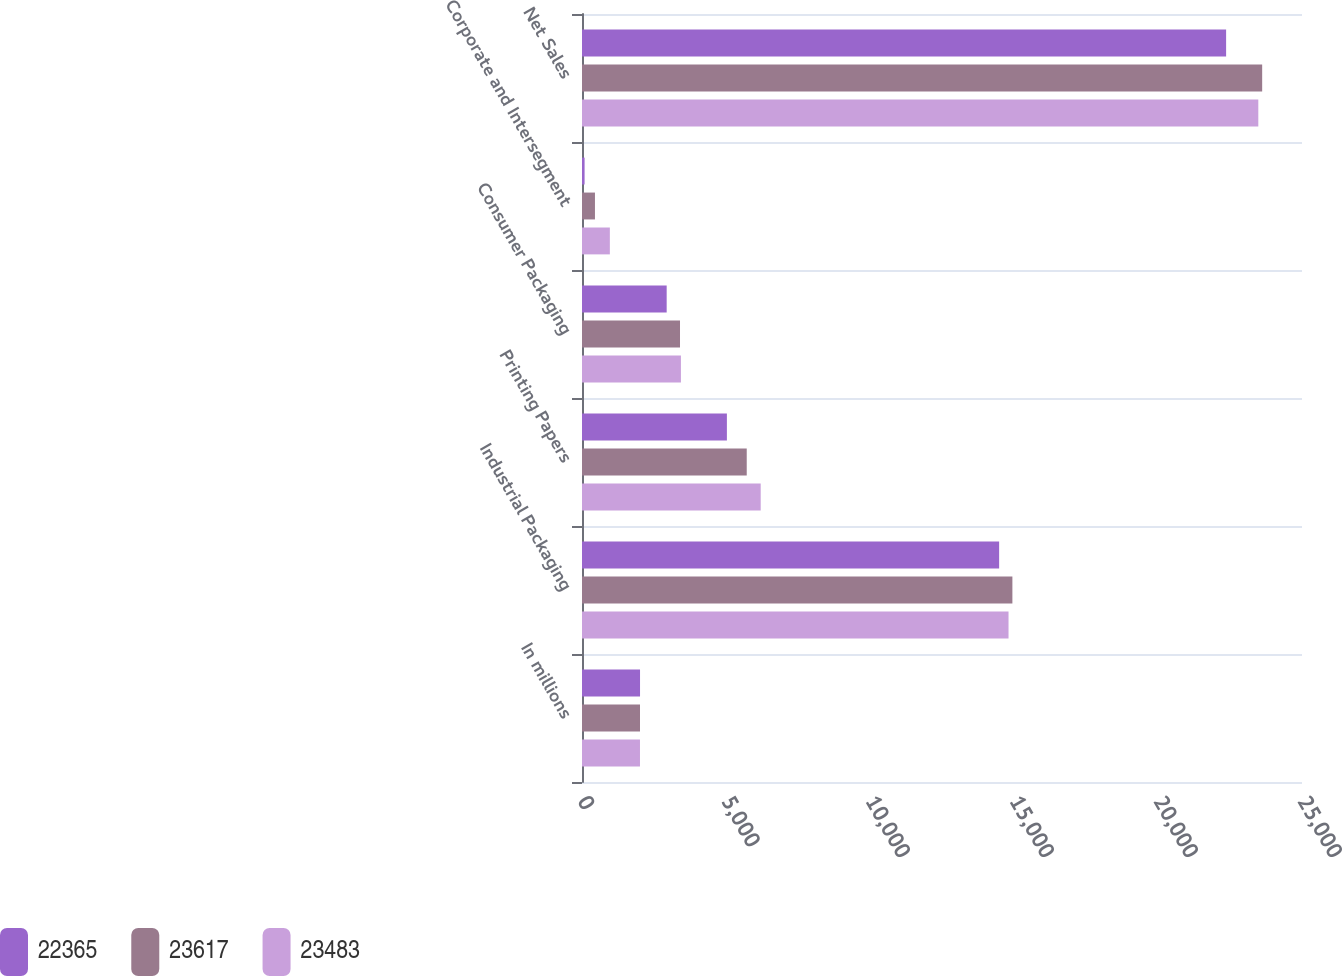Convert chart. <chart><loc_0><loc_0><loc_500><loc_500><stacked_bar_chart><ecel><fcel>In millions<fcel>Industrial Packaging<fcel>Printing Papers<fcel>Consumer Packaging<fcel>Corporate and Intersegment<fcel>Net Sales<nl><fcel>22365<fcel>2015<fcel>14484<fcel>5031<fcel>2940<fcel>90<fcel>22365<nl><fcel>23617<fcel>2014<fcel>14944<fcel>5720<fcel>3403<fcel>450<fcel>23617<nl><fcel>23483<fcel>2013<fcel>14810<fcel>6205<fcel>3435<fcel>967<fcel>23483<nl></chart> 